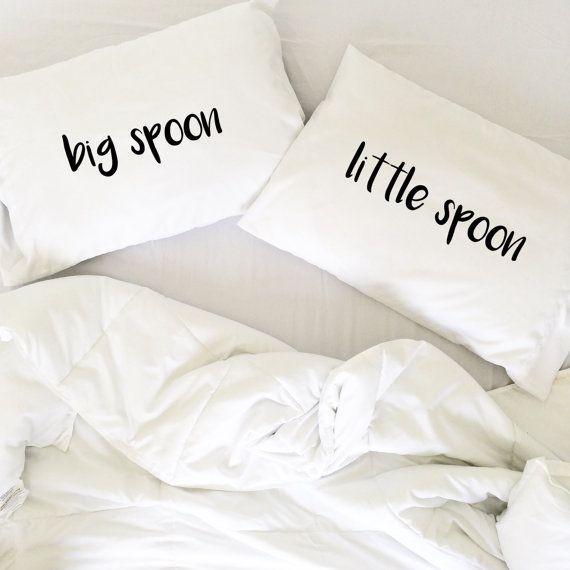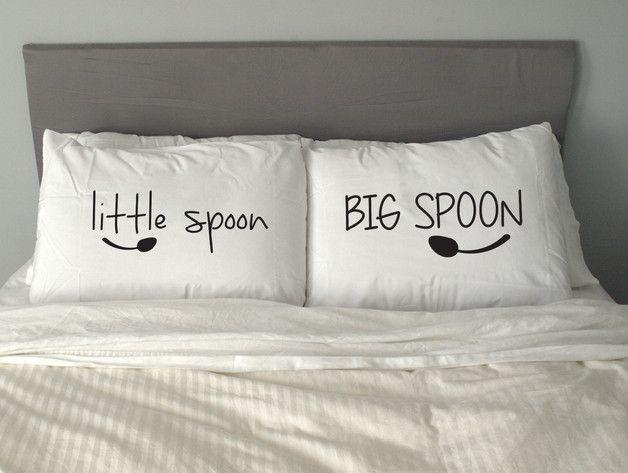The first image is the image on the left, the second image is the image on the right. Evaluate the accuracy of this statement regarding the images: "A pair of pillows are printed with spoon shapes below lettering.". Is it true? Answer yes or no. Yes. The first image is the image on the left, the second image is the image on the right. Analyze the images presented: Is the assertion "All big spoons are to the left." valid? Answer yes or no. No. 